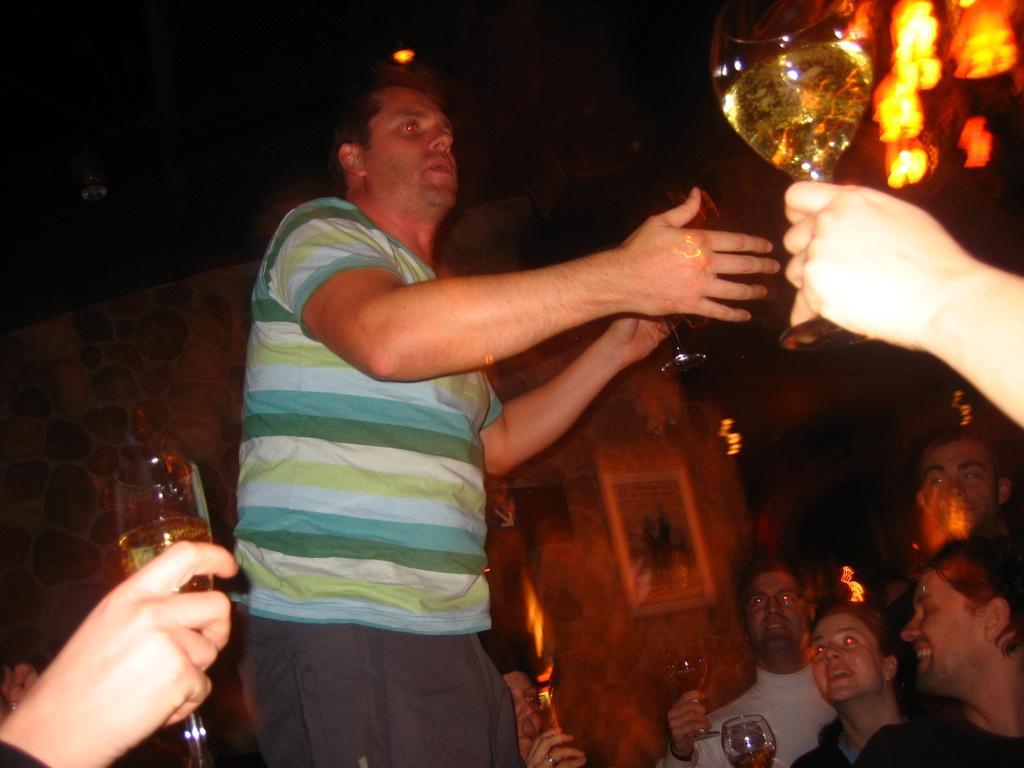Could you give a brief overview of what you see in this image? This picture shows a man standing on the floor. Around him there are some people sitting, holding a wine glasses in their hands. In the background there is a light and a photo frame attached to the wall. 